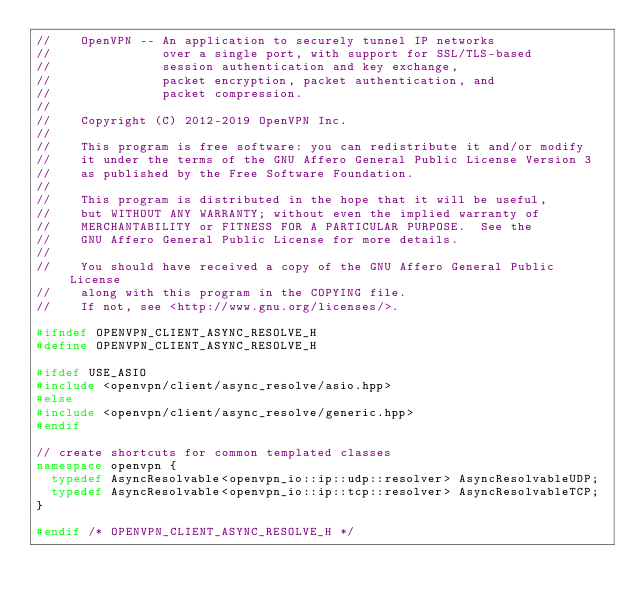<code> <loc_0><loc_0><loc_500><loc_500><_C++_>//    OpenVPN -- An application to securely tunnel IP networks
//               over a single port, with support for SSL/TLS-based
//               session authentication and key exchange,
//               packet encryption, packet authentication, and
//               packet compression.
//
//    Copyright (C) 2012-2019 OpenVPN Inc.
//
//    This program is free software: you can redistribute it and/or modify
//    it under the terms of the GNU Affero General Public License Version 3
//    as published by the Free Software Foundation.
//
//    This program is distributed in the hope that it will be useful,
//    but WITHOUT ANY WARRANTY; without even the implied warranty of
//    MERCHANTABILITY or FITNESS FOR A PARTICULAR PURPOSE.  See the
//    GNU Affero General Public License for more details.
//
//    You should have received a copy of the GNU Affero General Public License
//    along with this program in the COPYING file.
//    If not, see <http://www.gnu.org/licenses/>.

#ifndef OPENVPN_CLIENT_ASYNC_RESOLVE_H
#define OPENVPN_CLIENT_ASYNC_RESOLVE_H

#ifdef USE_ASIO
#include <openvpn/client/async_resolve/asio.hpp>
#else
#include <openvpn/client/async_resolve/generic.hpp>
#endif

// create shortcuts for common templated classes
namespace openvpn {
  typedef AsyncResolvable<openvpn_io::ip::udp::resolver> AsyncResolvableUDP;
  typedef AsyncResolvable<openvpn_io::ip::tcp::resolver> AsyncResolvableTCP;
}

#endif /* OPENVPN_CLIENT_ASYNC_RESOLVE_H */
</code> 